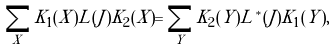Convert formula to latex. <formula><loc_0><loc_0><loc_500><loc_500>\sum _ { X } K _ { 1 } ( X ) L ( J ) K _ { 2 } ( X ) = \sum _ { Y } K _ { 2 } ( Y ) L ^ { * } ( J ) K _ { 1 } ( Y ) ,</formula> 